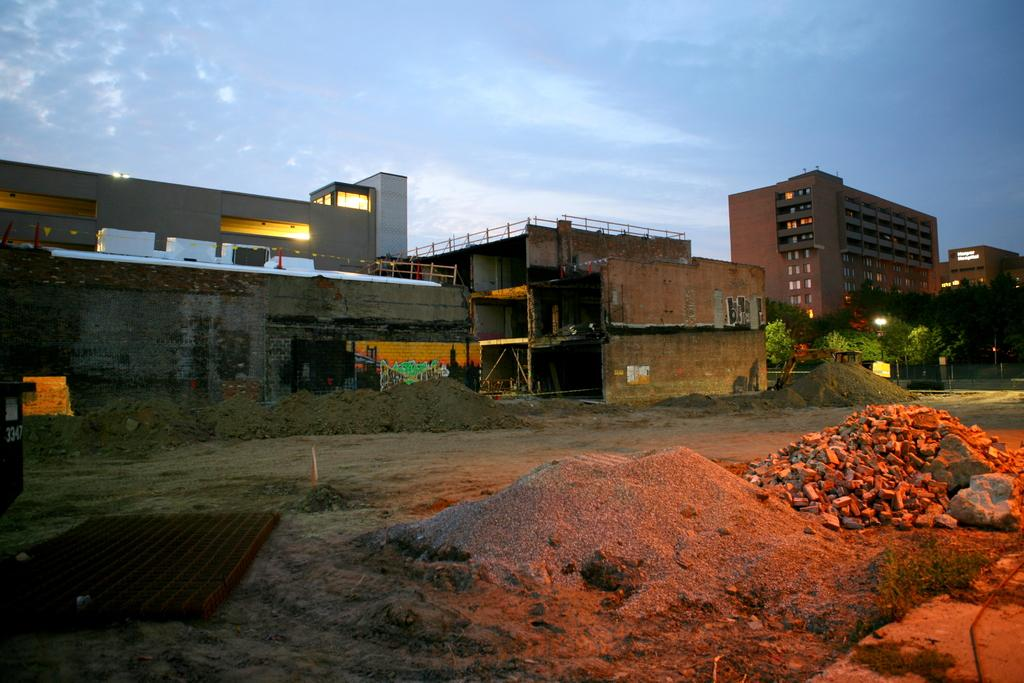What type of structures can be seen in the image? There are buildings in the image. What else is visible in the image besides the buildings? There are lights, trees, a vehicle, and rocks on the right side of the image. Where is the market located in the image? There is no market present in the image. Can you tell me what type of lawyer is depicted in the image? There is no lawyer present in the image. 